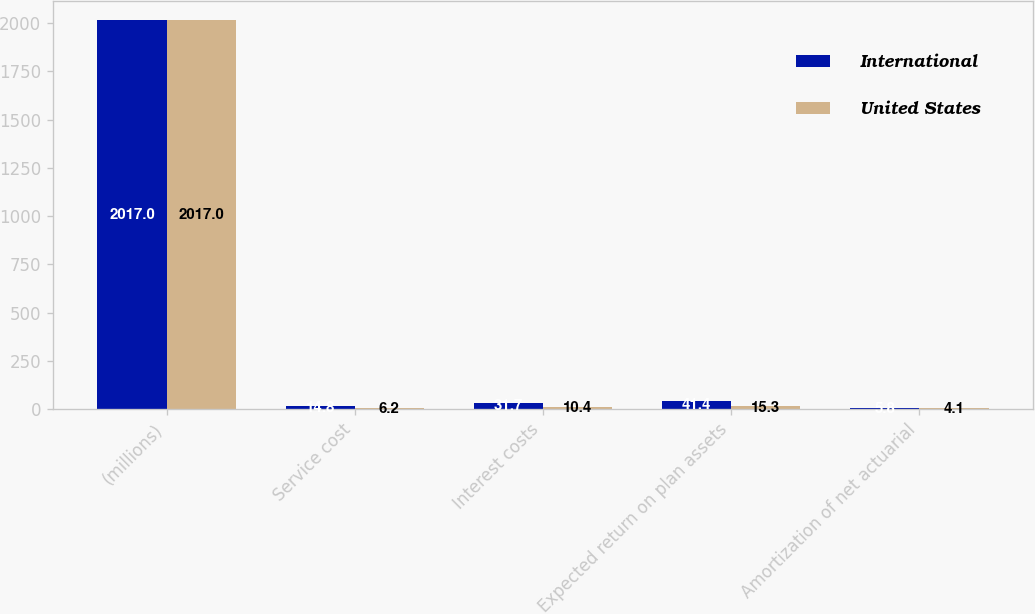<chart> <loc_0><loc_0><loc_500><loc_500><stacked_bar_chart><ecel><fcel>(millions)<fcel>Service cost<fcel>Interest costs<fcel>Expected return on plan assets<fcel>Amortization of net actuarial<nl><fcel>International<fcel>2017<fcel>14.8<fcel>31.7<fcel>41.4<fcel>5.8<nl><fcel>United States<fcel>2017<fcel>6.2<fcel>10.4<fcel>15.3<fcel>4.1<nl></chart> 